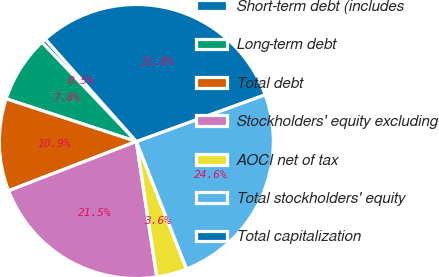<chart> <loc_0><loc_0><loc_500><loc_500><pie_chart><fcel>Short-term debt (includes<fcel>Long-term debt<fcel>Total debt<fcel>Stockholders' equity excluding<fcel>AOCI net of tax<fcel>Total stockholders' equity<fcel>Total capitalization<nl><fcel>0.54%<fcel>7.85%<fcel>10.9%<fcel>21.53%<fcel>3.59%<fcel>24.58%<fcel>31.03%<nl></chart> 